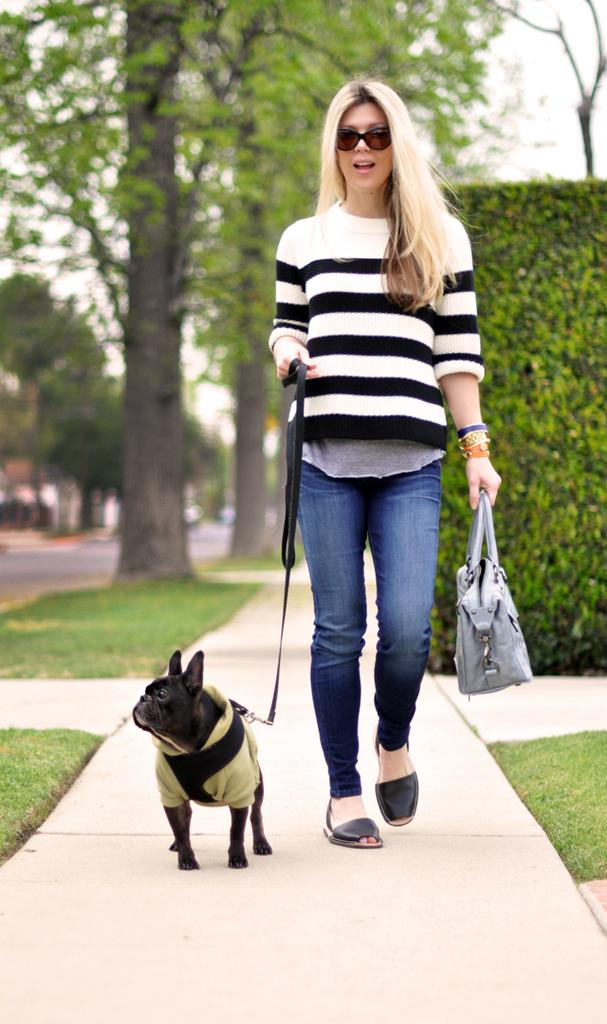Who is present in the image? There is a woman in the image. What is the woman wearing? The woman is wearing a white and black stripe t-shirt. What is the woman doing in the image? The woman is walking on a pedestrian path. What is the woman holding in the image? The woman is holding a dog leash. What can be seen in the background of the image? There are trees and plants in the background of the image. Can you see any goats running along the waves in the image? There are no goats or waves present in the image; it features a woman walking on a pedestrian path with trees and plants in the background. 